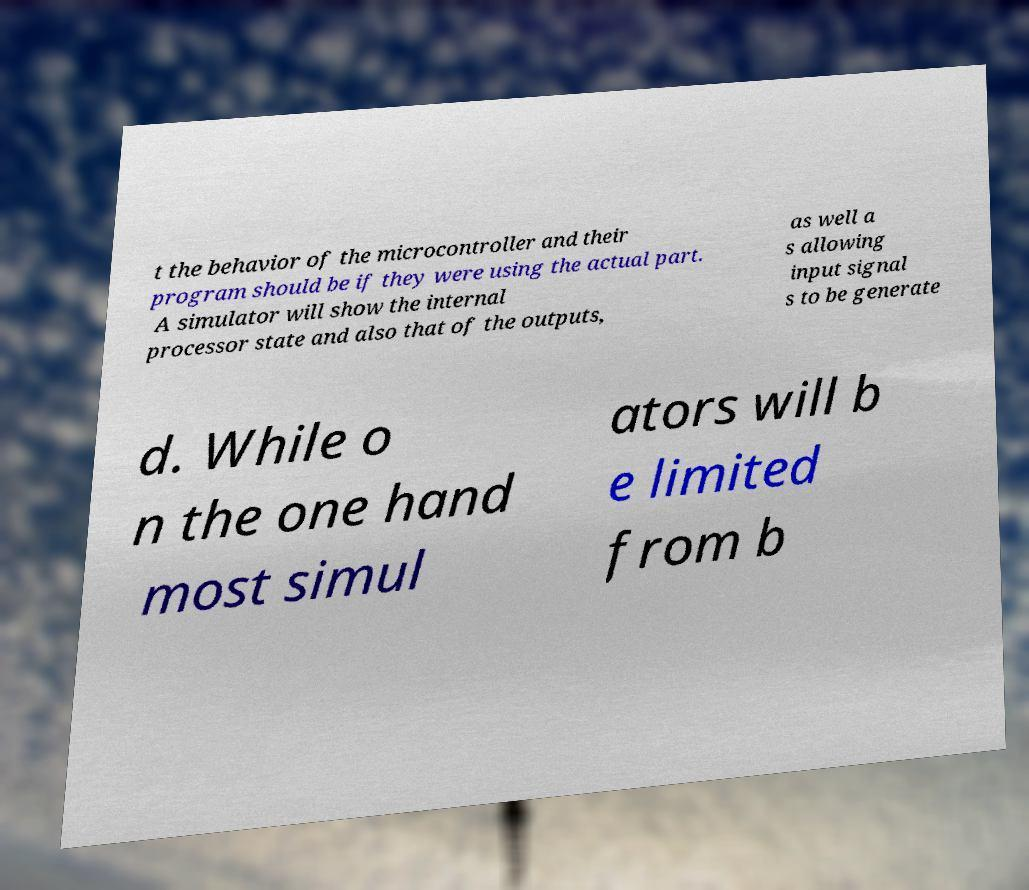There's text embedded in this image that I need extracted. Can you transcribe it verbatim? t the behavior of the microcontroller and their program should be if they were using the actual part. A simulator will show the internal processor state and also that of the outputs, as well a s allowing input signal s to be generate d. While o n the one hand most simul ators will b e limited from b 